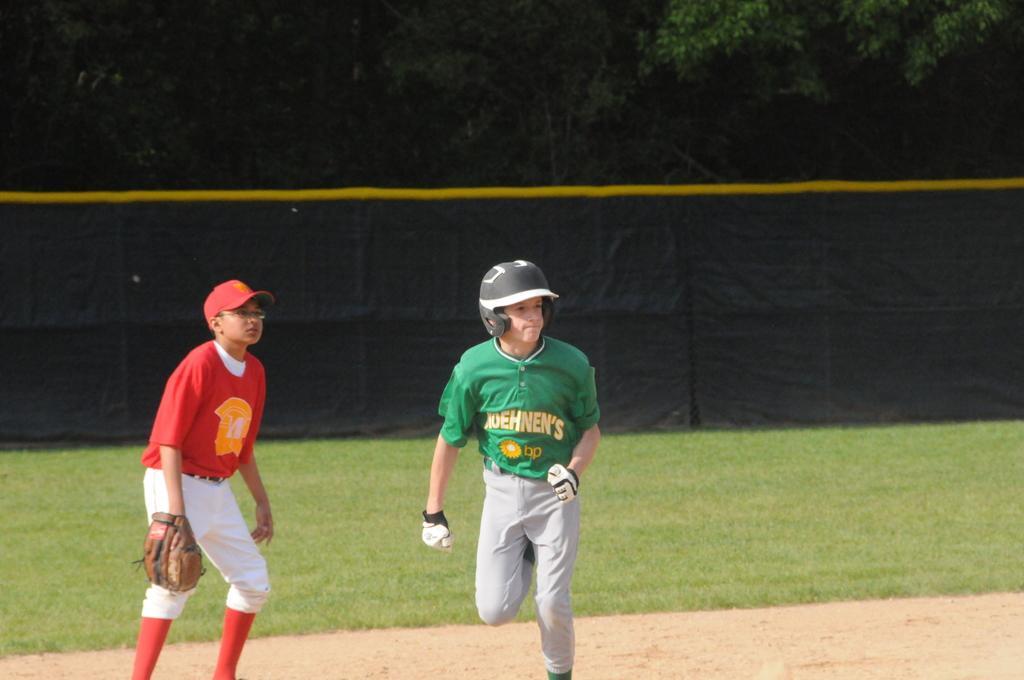In one or two sentences, can you explain what this image depicts? In this image, we can see two persons are wearing goggles. At the bottom, we can see the ground. Background we can see grass, cloth and trees. 